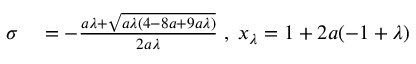<formula> <loc_0><loc_0><loc_500><loc_500>\begin{array} { r l } { \sigma } & = - \frac { a \lambda + \sqrt { a \lambda ( 4 - 8 a + 9 a \lambda ) } } { 2 a \lambda } \, , \, x _ { \lambda } = 1 + 2 a ( - 1 + \lambda ) } \end{array}</formula> 